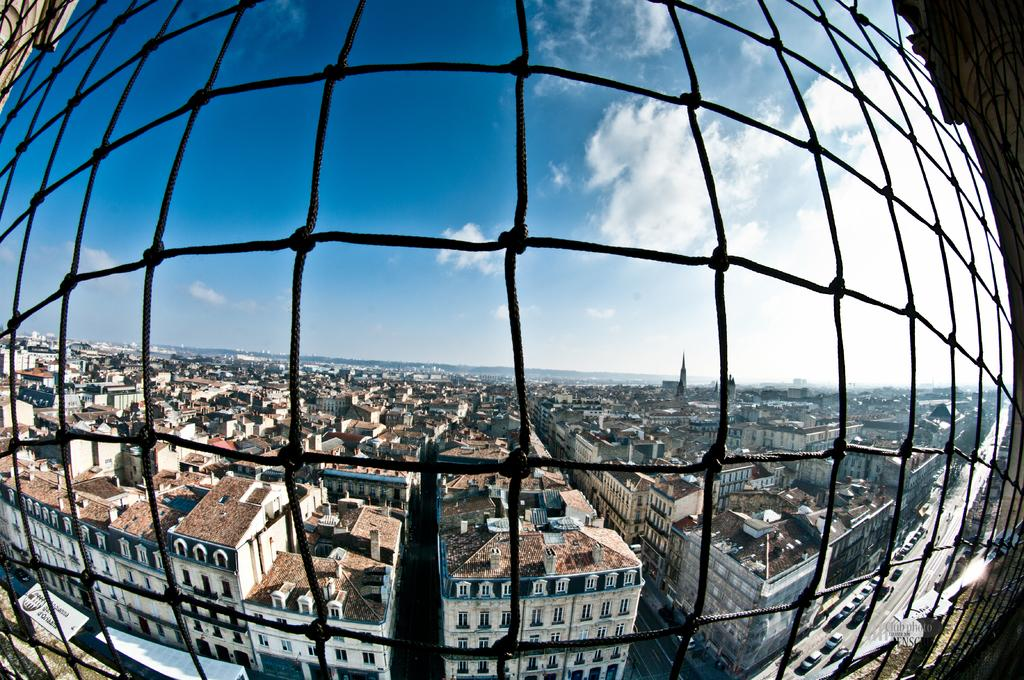What type of structure can be seen in the image? There is a fence in the image. What else can be seen in the image besides the fence? There are buildings and vehicles in the image. What is visible in the sky in the image? Clouds are visible in the image. What type of farm animals can be seen in the image? There are no farm animals present in the image. Is there a spy observing the scene in the image? There is no indication of a spy or any surveillance activity in the image. 